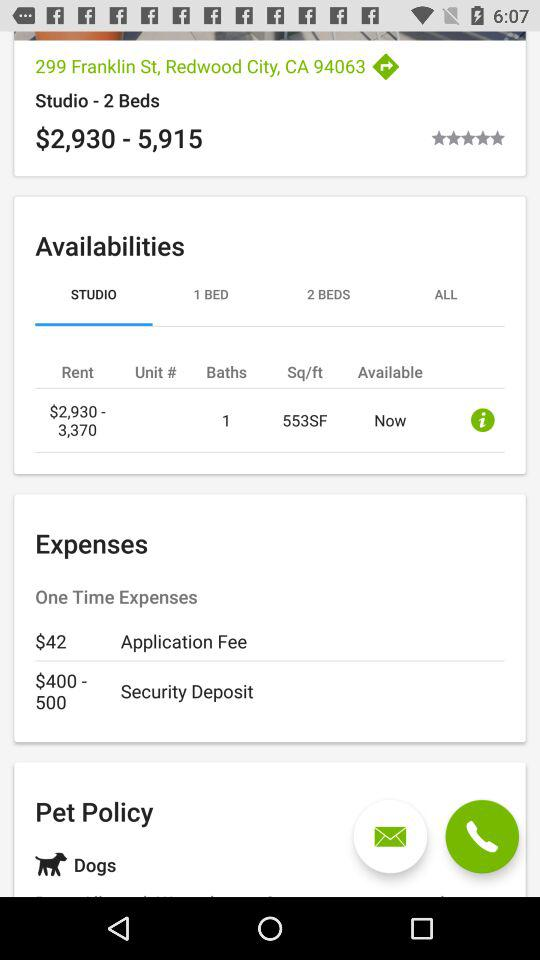What are the total beds available in the studio? There is 1 bed available in the studio. 